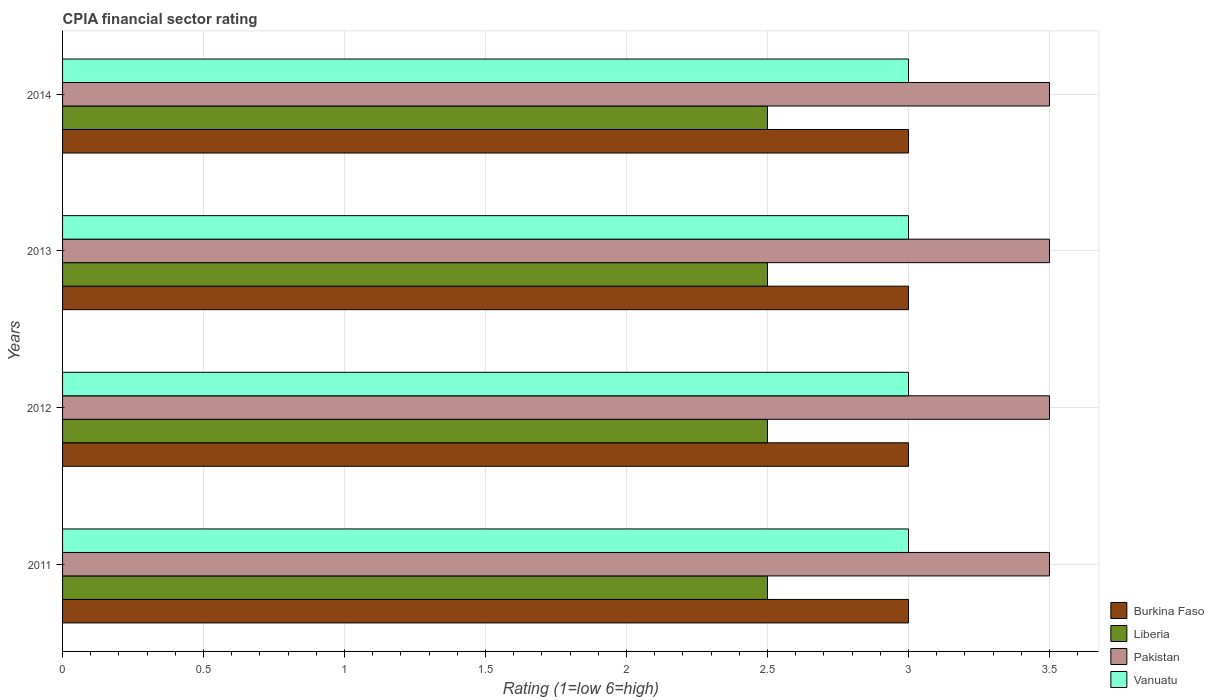How many different coloured bars are there?
Keep it short and to the point. 4. Are the number of bars on each tick of the Y-axis equal?
Your answer should be compact. Yes. How many bars are there on the 3rd tick from the top?
Your answer should be very brief. 4. How many bars are there on the 3rd tick from the bottom?
Offer a terse response. 4. What is the label of the 2nd group of bars from the top?
Make the answer very short. 2013. Across all years, what is the maximum CPIA rating in Liberia?
Offer a very short reply. 2.5. Across all years, what is the minimum CPIA rating in Burkina Faso?
Ensure brevity in your answer.  3. In which year was the CPIA rating in Burkina Faso minimum?
Ensure brevity in your answer.  2011. What is the total CPIA rating in Vanuatu in the graph?
Your answer should be very brief. 12. What is the difference between the CPIA rating in Liberia in 2013 and that in 2014?
Offer a terse response. 0. In the year 2012, what is the difference between the CPIA rating in Pakistan and CPIA rating in Liberia?
Your answer should be very brief. 1. In how many years, is the CPIA rating in Liberia greater than 2.6 ?
Provide a succinct answer. 0. What is the difference between the highest and the lowest CPIA rating in Liberia?
Your answer should be very brief. 0. Is the sum of the CPIA rating in Vanuatu in 2011 and 2012 greater than the maximum CPIA rating in Burkina Faso across all years?
Ensure brevity in your answer.  Yes. What does the 1st bar from the top in 2014 represents?
Make the answer very short. Vanuatu. What does the 1st bar from the bottom in 2013 represents?
Offer a terse response. Burkina Faso. Is it the case that in every year, the sum of the CPIA rating in Burkina Faso and CPIA rating in Liberia is greater than the CPIA rating in Vanuatu?
Your answer should be very brief. Yes. How many bars are there?
Offer a terse response. 16. How many years are there in the graph?
Ensure brevity in your answer.  4. What is the difference between two consecutive major ticks on the X-axis?
Provide a succinct answer. 0.5. Are the values on the major ticks of X-axis written in scientific E-notation?
Your answer should be compact. No. Does the graph contain any zero values?
Make the answer very short. No. Where does the legend appear in the graph?
Give a very brief answer. Bottom right. What is the title of the graph?
Your answer should be compact. CPIA financial sector rating. What is the label or title of the X-axis?
Give a very brief answer. Rating (1=low 6=high). What is the Rating (1=low 6=high) in Burkina Faso in 2011?
Offer a terse response. 3. What is the Rating (1=low 6=high) in Liberia in 2011?
Ensure brevity in your answer.  2.5. What is the Rating (1=low 6=high) of Vanuatu in 2011?
Ensure brevity in your answer.  3. What is the Rating (1=low 6=high) in Burkina Faso in 2012?
Provide a short and direct response. 3. What is the Rating (1=low 6=high) of Vanuatu in 2012?
Ensure brevity in your answer.  3. What is the Rating (1=low 6=high) of Burkina Faso in 2013?
Give a very brief answer. 3. What is the Rating (1=low 6=high) in Vanuatu in 2013?
Offer a terse response. 3. Across all years, what is the maximum Rating (1=low 6=high) in Vanuatu?
Your response must be concise. 3. Across all years, what is the minimum Rating (1=low 6=high) in Burkina Faso?
Offer a very short reply. 3. Across all years, what is the minimum Rating (1=low 6=high) in Liberia?
Your answer should be compact. 2.5. Across all years, what is the minimum Rating (1=low 6=high) of Vanuatu?
Your response must be concise. 3. What is the total Rating (1=low 6=high) of Burkina Faso in the graph?
Offer a very short reply. 12. What is the total Rating (1=low 6=high) of Liberia in the graph?
Your response must be concise. 10. What is the difference between the Rating (1=low 6=high) of Burkina Faso in 2011 and that in 2012?
Ensure brevity in your answer.  0. What is the difference between the Rating (1=low 6=high) of Burkina Faso in 2011 and that in 2014?
Your answer should be very brief. 0. What is the difference between the Rating (1=low 6=high) in Liberia in 2011 and that in 2014?
Your response must be concise. 0. What is the difference between the Rating (1=low 6=high) of Burkina Faso in 2012 and that in 2013?
Your answer should be very brief. 0. What is the difference between the Rating (1=low 6=high) in Liberia in 2012 and that in 2013?
Ensure brevity in your answer.  0. What is the difference between the Rating (1=low 6=high) in Pakistan in 2012 and that in 2013?
Offer a very short reply. 0. What is the difference between the Rating (1=low 6=high) in Vanuatu in 2012 and that in 2013?
Your answer should be compact. 0. What is the difference between the Rating (1=low 6=high) in Liberia in 2012 and that in 2014?
Give a very brief answer. 0. What is the difference between the Rating (1=low 6=high) of Pakistan in 2013 and that in 2014?
Give a very brief answer. 0. What is the difference between the Rating (1=low 6=high) in Vanuatu in 2013 and that in 2014?
Offer a very short reply. 0. What is the difference between the Rating (1=low 6=high) in Burkina Faso in 2011 and the Rating (1=low 6=high) in Liberia in 2012?
Offer a terse response. 0.5. What is the difference between the Rating (1=low 6=high) of Burkina Faso in 2011 and the Rating (1=low 6=high) of Pakistan in 2012?
Your answer should be very brief. -0.5. What is the difference between the Rating (1=low 6=high) in Liberia in 2011 and the Rating (1=low 6=high) in Pakistan in 2012?
Your answer should be compact. -1. What is the difference between the Rating (1=low 6=high) in Liberia in 2011 and the Rating (1=low 6=high) in Vanuatu in 2012?
Make the answer very short. -0.5. What is the difference between the Rating (1=low 6=high) of Liberia in 2011 and the Rating (1=low 6=high) of Pakistan in 2013?
Provide a succinct answer. -1. What is the difference between the Rating (1=low 6=high) in Liberia in 2011 and the Rating (1=low 6=high) in Vanuatu in 2013?
Provide a short and direct response. -0.5. What is the difference between the Rating (1=low 6=high) of Burkina Faso in 2011 and the Rating (1=low 6=high) of Liberia in 2014?
Make the answer very short. 0.5. What is the difference between the Rating (1=low 6=high) of Burkina Faso in 2011 and the Rating (1=low 6=high) of Pakistan in 2014?
Your response must be concise. -0.5. What is the difference between the Rating (1=low 6=high) of Liberia in 2011 and the Rating (1=low 6=high) of Pakistan in 2014?
Your answer should be very brief. -1. What is the difference between the Rating (1=low 6=high) of Liberia in 2011 and the Rating (1=low 6=high) of Vanuatu in 2014?
Make the answer very short. -0.5. What is the difference between the Rating (1=low 6=high) in Pakistan in 2011 and the Rating (1=low 6=high) in Vanuatu in 2014?
Provide a succinct answer. 0.5. What is the difference between the Rating (1=low 6=high) in Burkina Faso in 2012 and the Rating (1=low 6=high) in Liberia in 2013?
Offer a terse response. 0.5. What is the difference between the Rating (1=low 6=high) of Burkina Faso in 2012 and the Rating (1=low 6=high) of Vanuatu in 2013?
Offer a very short reply. 0. What is the difference between the Rating (1=low 6=high) in Liberia in 2012 and the Rating (1=low 6=high) in Pakistan in 2013?
Offer a terse response. -1. What is the difference between the Rating (1=low 6=high) in Liberia in 2012 and the Rating (1=low 6=high) in Vanuatu in 2013?
Your response must be concise. -0.5. What is the difference between the Rating (1=low 6=high) in Burkina Faso in 2012 and the Rating (1=low 6=high) in Liberia in 2014?
Keep it short and to the point. 0.5. What is the difference between the Rating (1=low 6=high) in Liberia in 2012 and the Rating (1=low 6=high) in Pakistan in 2014?
Your answer should be compact. -1. What is the difference between the Rating (1=low 6=high) of Burkina Faso in 2013 and the Rating (1=low 6=high) of Vanuatu in 2014?
Your response must be concise. 0. What is the difference between the Rating (1=low 6=high) of Liberia in 2013 and the Rating (1=low 6=high) of Pakistan in 2014?
Offer a very short reply. -1. What is the difference between the Rating (1=low 6=high) of Pakistan in 2013 and the Rating (1=low 6=high) of Vanuatu in 2014?
Your answer should be compact. 0.5. In the year 2011, what is the difference between the Rating (1=low 6=high) of Burkina Faso and Rating (1=low 6=high) of Liberia?
Your answer should be compact. 0.5. In the year 2011, what is the difference between the Rating (1=low 6=high) of Burkina Faso and Rating (1=low 6=high) of Vanuatu?
Provide a short and direct response. 0. In the year 2011, what is the difference between the Rating (1=low 6=high) in Liberia and Rating (1=low 6=high) in Pakistan?
Offer a very short reply. -1. In the year 2012, what is the difference between the Rating (1=low 6=high) of Liberia and Rating (1=low 6=high) of Pakistan?
Your response must be concise. -1. In the year 2012, what is the difference between the Rating (1=low 6=high) in Liberia and Rating (1=low 6=high) in Vanuatu?
Keep it short and to the point. -0.5. In the year 2013, what is the difference between the Rating (1=low 6=high) in Burkina Faso and Rating (1=low 6=high) in Liberia?
Make the answer very short. 0.5. In the year 2013, what is the difference between the Rating (1=low 6=high) of Liberia and Rating (1=low 6=high) of Pakistan?
Make the answer very short. -1. In the year 2013, what is the difference between the Rating (1=low 6=high) of Liberia and Rating (1=low 6=high) of Vanuatu?
Your answer should be very brief. -0.5. In the year 2014, what is the difference between the Rating (1=low 6=high) of Burkina Faso and Rating (1=low 6=high) of Liberia?
Your response must be concise. 0.5. In the year 2014, what is the difference between the Rating (1=low 6=high) of Pakistan and Rating (1=low 6=high) of Vanuatu?
Your answer should be compact. 0.5. What is the ratio of the Rating (1=low 6=high) of Pakistan in 2011 to that in 2012?
Provide a short and direct response. 1. What is the ratio of the Rating (1=low 6=high) in Vanuatu in 2011 to that in 2012?
Ensure brevity in your answer.  1. What is the ratio of the Rating (1=low 6=high) of Liberia in 2011 to that in 2013?
Keep it short and to the point. 1. What is the ratio of the Rating (1=low 6=high) in Pakistan in 2011 to that in 2013?
Ensure brevity in your answer.  1. What is the ratio of the Rating (1=low 6=high) in Vanuatu in 2011 to that in 2013?
Offer a terse response. 1. What is the ratio of the Rating (1=low 6=high) in Burkina Faso in 2012 to that in 2014?
Offer a terse response. 1. What is the ratio of the Rating (1=low 6=high) of Liberia in 2012 to that in 2014?
Your answer should be very brief. 1. What is the ratio of the Rating (1=low 6=high) in Vanuatu in 2012 to that in 2014?
Make the answer very short. 1. What is the ratio of the Rating (1=low 6=high) in Burkina Faso in 2013 to that in 2014?
Keep it short and to the point. 1. What is the ratio of the Rating (1=low 6=high) of Vanuatu in 2013 to that in 2014?
Offer a very short reply. 1. What is the difference between the highest and the second highest Rating (1=low 6=high) in Burkina Faso?
Your answer should be compact. 0. What is the difference between the highest and the second highest Rating (1=low 6=high) in Liberia?
Your answer should be compact. 0. What is the difference between the highest and the lowest Rating (1=low 6=high) in Burkina Faso?
Offer a very short reply. 0. What is the difference between the highest and the lowest Rating (1=low 6=high) of Liberia?
Provide a succinct answer. 0. What is the difference between the highest and the lowest Rating (1=low 6=high) in Vanuatu?
Your answer should be compact. 0. 